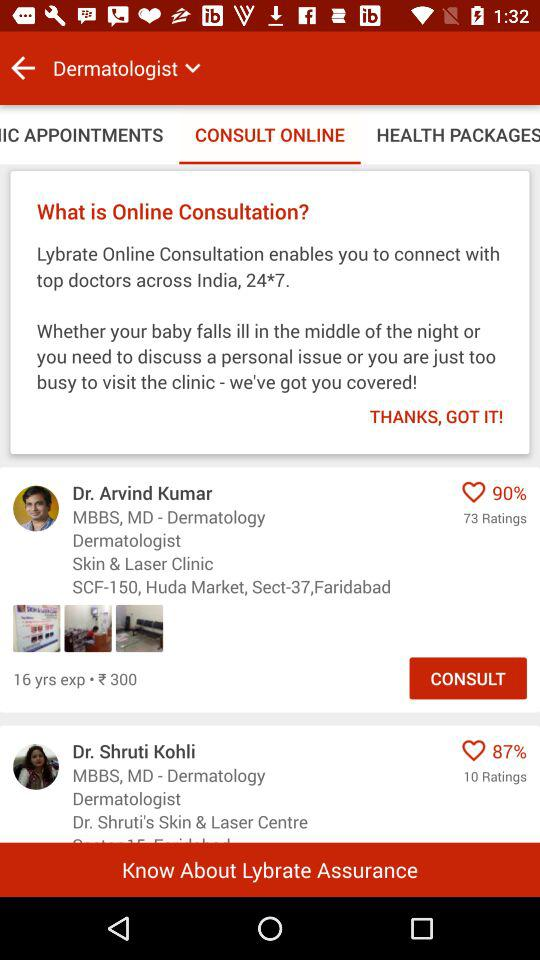How much experience does Dr. Arvind Kumar have? Dr. Arvind Kumar has 16 years of experience. 